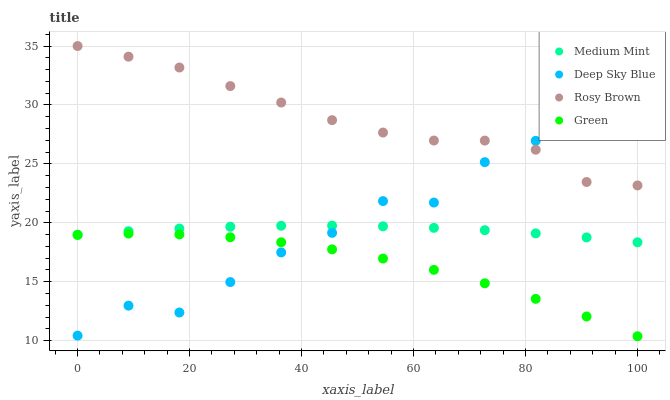Does Green have the minimum area under the curve?
Answer yes or no. Yes. Does Rosy Brown have the maximum area under the curve?
Answer yes or no. Yes. Does Rosy Brown have the minimum area under the curve?
Answer yes or no. No. Does Green have the maximum area under the curve?
Answer yes or no. No. Is Medium Mint the smoothest?
Answer yes or no. Yes. Is Deep Sky Blue the roughest?
Answer yes or no. Yes. Is Rosy Brown the smoothest?
Answer yes or no. No. Is Rosy Brown the roughest?
Answer yes or no. No. Does Green have the lowest value?
Answer yes or no. Yes. Does Rosy Brown have the lowest value?
Answer yes or no. No. Does Rosy Brown have the highest value?
Answer yes or no. Yes. Does Green have the highest value?
Answer yes or no. No. Is Medium Mint less than Rosy Brown?
Answer yes or no. Yes. Is Rosy Brown greater than Medium Mint?
Answer yes or no. Yes. Does Rosy Brown intersect Deep Sky Blue?
Answer yes or no. Yes. Is Rosy Brown less than Deep Sky Blue?
Answer yes or no. No. Is Rosy Brown greater than Deep Sky Blue?
Answer yes or no. No. Does Medium Mint intersect Rosy Brown?
Answer yes or no. No. 